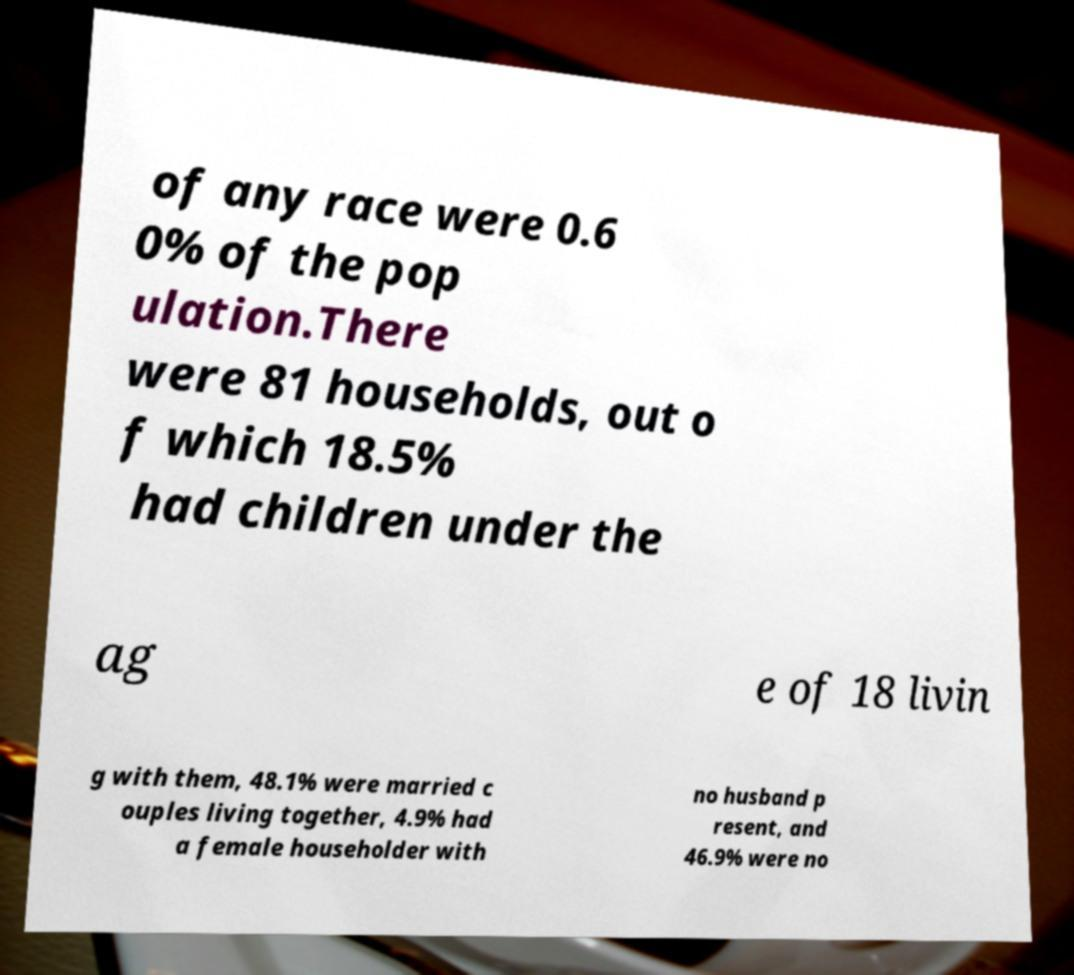I need the written content from this picture converted into text. Can you do that? of any race were 0.6 0% of the pop ulation.There were 81 households, out o f which 18.5% had children under the ag e of 18 livin g with them, 48.1% were married c ouples living together, 4.9% had a female householder with no husband p resent, and 46.9% were no 